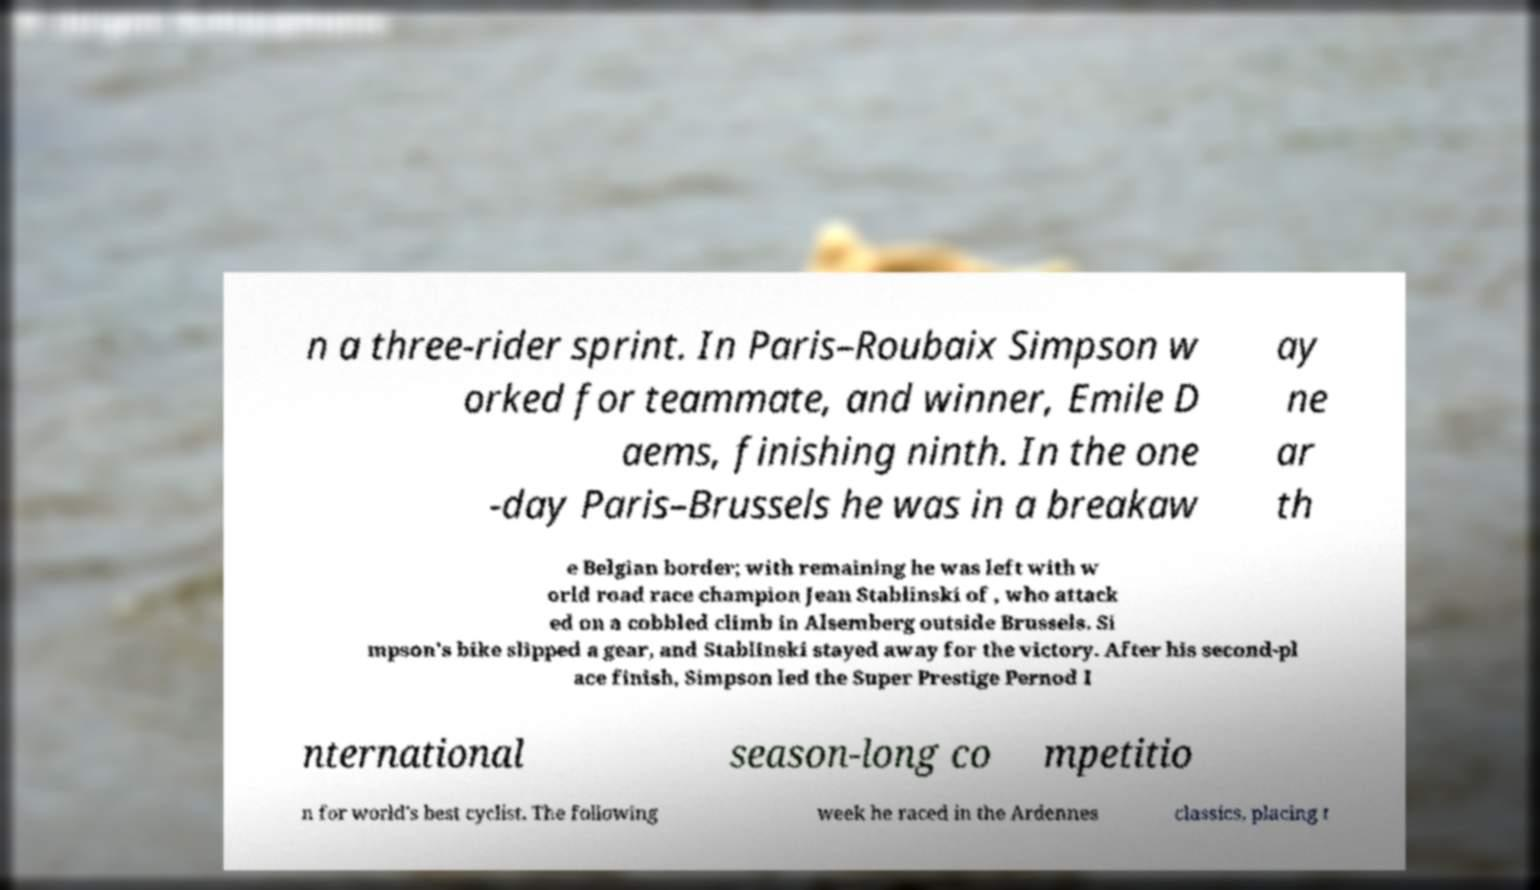Please identify and transcribe the text found in this image. n a three-rider sprint. In Paris–Roubaix Simpson w orked for teammate, and winner, Emile D aems, finishing ninth. In the one -day Paris–Brussels he was in a breakaw ay ne ar th e Belgian border; with remaining he was left with w orld road race champion Jean Stablinski of , who attack ed on a cobbled climb in Alsemberg outside Brussels. Si mpson's bike slipped a gear, and Stablinski stayed away for the victory. After his second-pl ace finish, Simpson led the Super Prestige Pernod I nternational season-long co mpetitio n for world's best cyclist. The following week he raced in the Ardennes classics, placing t 